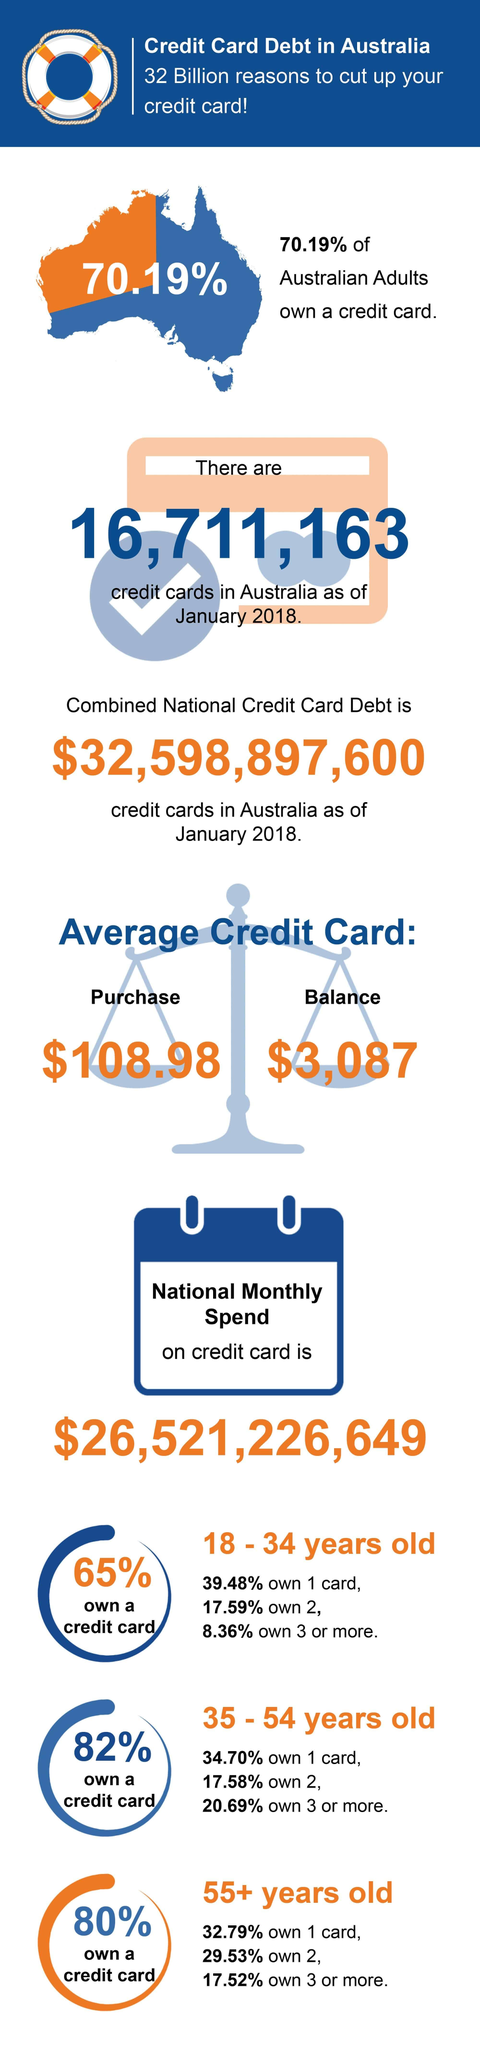Highlight a few significant elements in this photo. According to a recent survey, approximately 20% of Australians in the age group of 55+ years do not own a credit card. In January 2018, it was estimated that 29.81% of Australians did not own a credit card. A study has found that only 18% of Australians in the age group of 35-54 years do not own a credit card. A significant percentage, 35%, of Australians between the ages of 18 and 34 do not own a credit card. As of January 2018, the average credit card balance in Australia was estimated to be approximately $3,087. 